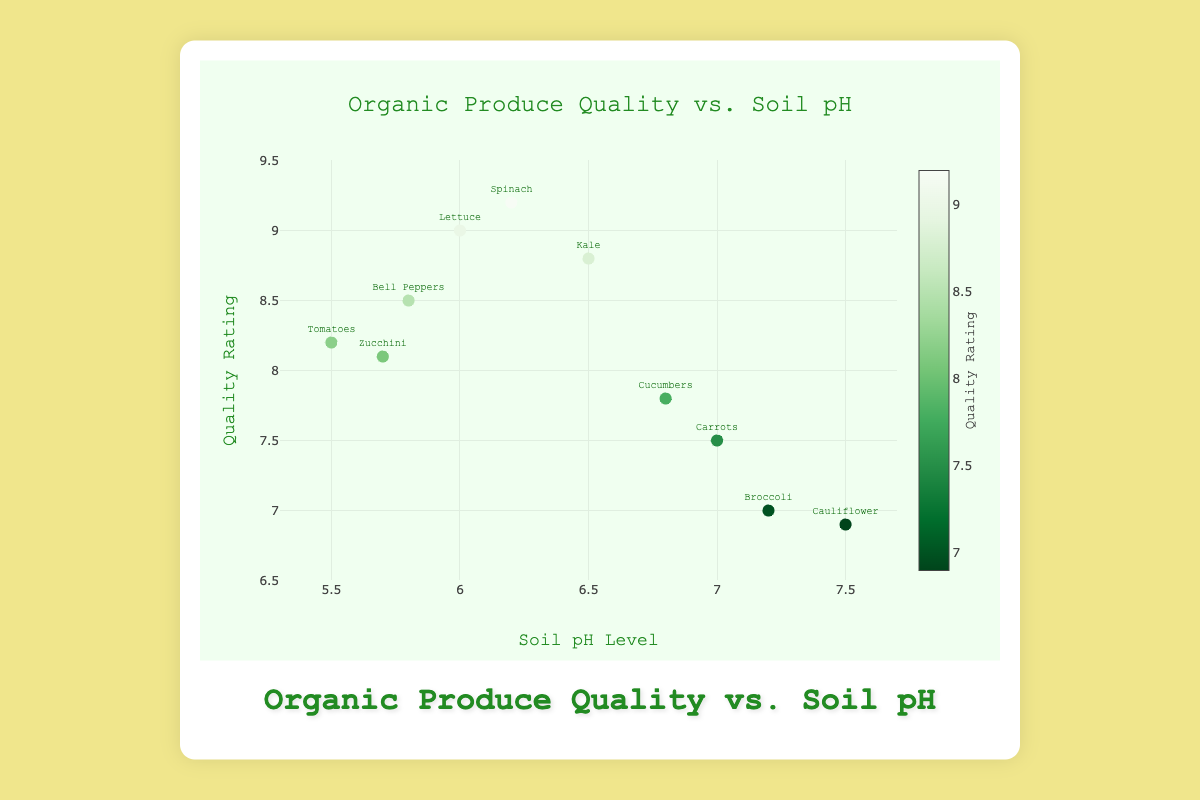What is the title of the figure? The title is usually prominently displayed at the top center of the chart. Reading it directly will provide the title of the figure.
Answer: Organic Produce Quality vs. Soil pH What is the range of Soil pH Level on the x-axis? By looking at the x-axis, you can observe the minimum and maximum values marked. These values represent the range of Soil pH Level on the x-axis.
Answer: 5.3 to 7.7 What is the median quality rating of the produce types shown? To find the median, first list all quality ratings in ascending order (6.9, 7.0, 7.5, 7.8, 8.1, 8.2, 8.5, 8.8, 9.0, 9.2). With 10 values, the median will be the average of the 5th and 6th values in the sorted list. Thus, (8.1 + 8.2) / 2 = 8.15.
Answer: 8.15 Which produce has the highest quality rating and what is the rating? By locating the point with the highest position along the y-axis, identifying its produce type label will reveal the answer. The point with the highest y value corresponds to Spinach.
Answer: Spinach with a rating of 9.2 Is there a general trend in the relationship between Soil pH Level and Quality Rating? By observing the trend line, notice if it inclines, declines, or stays constant. The trend line generally shows a slight downward slope indicating a negative relationship between Soil pH Level and Quality Rating.
Answer: Slight negative trend How many data points are there total on the scatter plot? By counting each marker on the plot representing different produce types, we can determine the total number of data points.
Answer: 10 For which Soil pH Level range does the highest quality produce fall, and what is the quality rating for it? The highest quality rating is 9.2, which is achieved by Spinach. Locate Spinach on the x-axis to determine the Soil pH Level range.
Answer: Soil pH Level 6.2 with Quality Rating 9.2 Which produce type has a Soil pH Level closest to neutral (pH 7) and what is its quality rating? Find the produce type marked closest to the x-axis value 7 and observe its corresponding y value. Carrots have a Soil pH Level of 7 with a Quality Rating of 7.5.
Answer: Carrots with a rating of 7.5 Does Broccoli have a higher or lower quality rating compared to Kale? Identify and compare the y values for both Broccoli and Kale. Broccoli has a quality rating of 7.0, whereas Kale has a quality rating of 8.8.
Answer: Lower What is the average quality rating for produce grown in Soil pH Levels between 6.0 and 7.0? First identify the data points within the specified Soil pH range (6.0, 6.2, 6.5, and 6.8). Their quality ratings are 9.0, 9.2, 8.8, and 7.8 respectively. Summing these gives 34.8, and dividing by the 4 data points results in an average of (34.8 / 4) = 8.7.
Answer: 8.7 